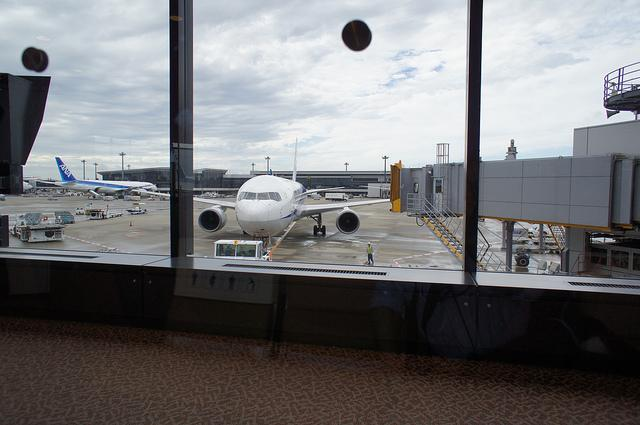Why does the man wear a yellow vest?

Choices:
A) visibility
B) dress code
C) camouflage
D) fashion visibility 